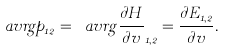<formula> <loc_0><loc_0><loc_500><loc_500>\ a v r g { p } _ { 1 2 } = \ a v r g { \frac { \partial H } { \partial v } } _ { 1 , 2 } = \frac { \partial E _ { 1 , 2 } } { \partial v } .</formula> 